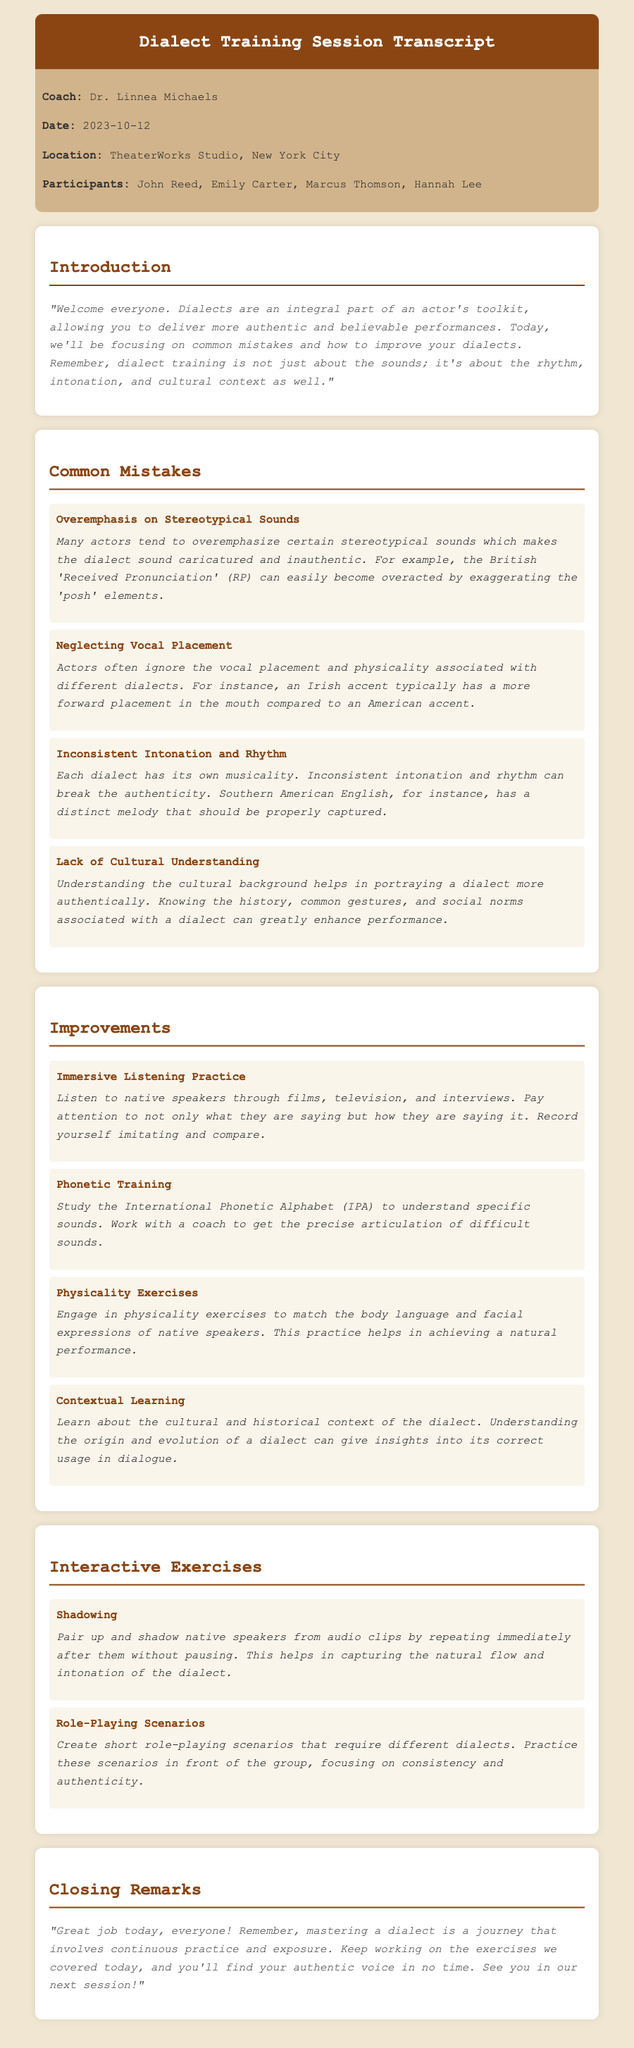What is the name of the dialect coach? The document states that the dialect coach leading the session is named Dr. Linnea Michaels.
Answer: Dr. Linnea Michaels When did the training session take place? The transcript indicates that the training session occurred on October 12, 2023.
Answer: 2023-10-12 Where was the training session held? The location of the training session is mentioned as TheaterWorks Studio, New York City.
Answer: TheaterWorks Studio, New York City What is one common mistake mentioned regarding dialects? The document lists "Overemphasis on Stereotypical Sounds" as one of the common mistakes actors make when working with dialects.
Answer: Overemphasis on Stereotypical Sounds What is the suggested improvement related to listening? The suggestion to enhance skills includes "Immersive Listening Practice," emphasizing listening to native speakers.
Answer: Immersive Listening Practice What type of exercise is suggested for practicing dialects? Among the exercises, "Shadowing" is mentioned as a way to practice dialects.
Answer: Shadowing According to the coach, what aspect of dialects does cultural understanding help with? The document states that cultural understanding is crucial for portraying dialects more authentically.
Answer: Portraying dialects more authentically How many participants were listed in the session? The document indicates that the total number of participants in the session was four.
Answer: Four What did the coach emphasize about mastering a dialect? The closing remarks highlight that mastering a dialect is a journey involving continuous practice and exposure.
Answer: Continuous practice and exposure 